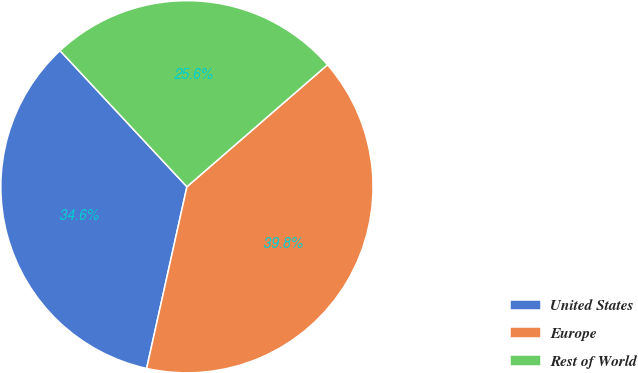<chart> <loc_0><loc_0><loc_500><loc_500><pie_chart><fcel>United States<fcel>Europe<fcel>Rest of World<nl><fcel>34.58%<fcel>39.85%<fcel>25.57%<nl></chart> 